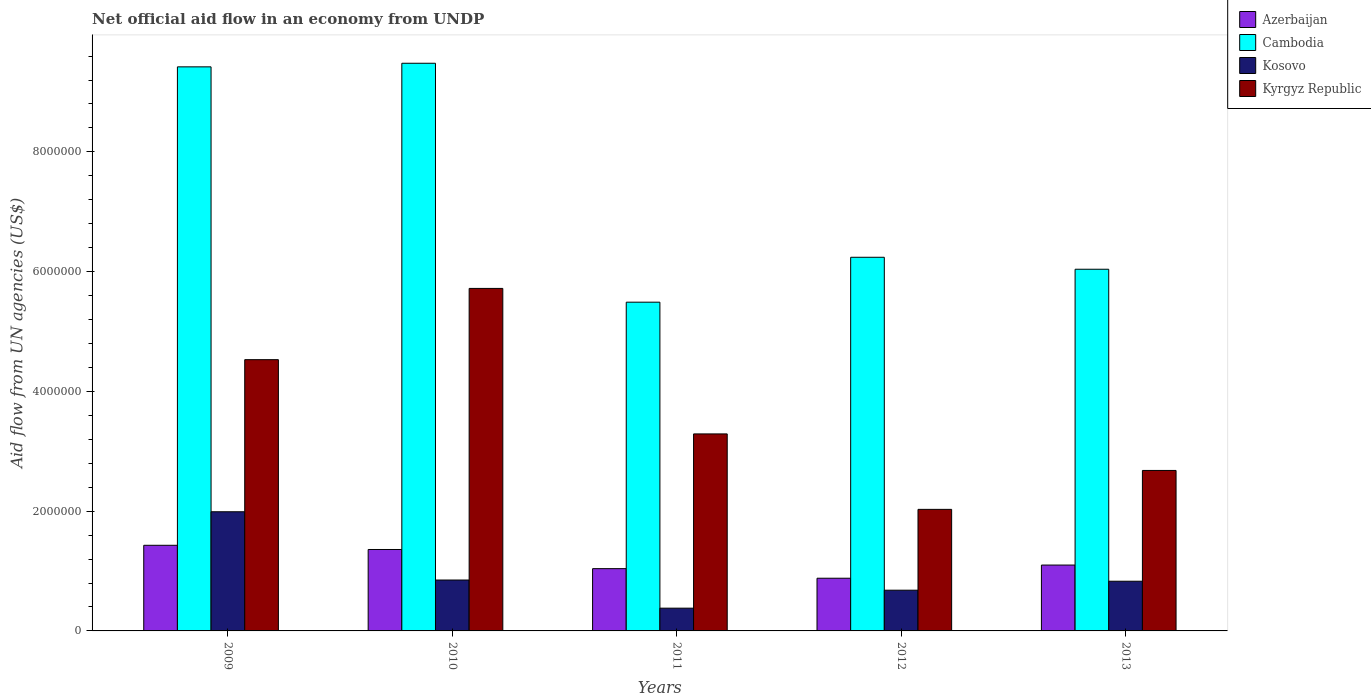How many different coloured bars are there?
Keep it short and to the point. 4. How many bars are there on the 4th tick from the left?
Your answer should be very brief. 4. How many bars are there on the 3rd tick from the right?
Provide a succinct answer. 4. What is the net official aid flow in Cambodia in 2013?
Keep it short and to the point. 6.04e+06. Across all years, what is the maximum net official aid flow in Kosovo?
Keep it short and to the point. 1.99e+06. Across all years, what is the minimum net official aid flow in Azerbaijan?
Give a very brief answer. 8.80e+05. In which year was the net official aid flow in Kosovo maximum?
Keep it short and to the point. 2009. What is the total net official aid flow in Cambodia in the graph?
Provide a short and direct response. 3.67e+07. What is the difference between the net official aid flow in Azerbaijan in 2011 and that in 2013?
Offer a very short reply. -6.00e+04. What is the difference between the net official aid flow in Azerbaijan in 2011 and the net official aid flow in Cambodia in 2009?
Make the answer very short. -8.38e+06. What is the average net official aid flow in Kyrgyz Republic per year?
Make the answer very short. 3.65e+06. In the year 2013, what is the difference between the net official aid flow in Kosovo and net official aid flow in Cambodia?
Offer a very short reply. -5.21e+06. In how many years, is the net official aid flow in Kyrgyz Republic greater than 5600000 US$?
Offer a very short reply. 1. What is the ratio of the net official aid flow in Kosovo in 2009 to that in 2012?
Ensure brevity in your answer.  2.93. Is the difference between the net official aid flow in Kosovo in 2011 and 2012 greater than the difference between the net official aid flow in Cambodia in 2011 and 2012?
Give a very brief answer. Yes. What is the difference between the highest and the second highest net official aid flow in Kyrgyz Republic?
Give a very brief answer. 1.19e+06. What is the difference between the highest and the lowest net official aid flow in Cambodia?
Your response must be concise. 3.99e+06. Is the sum of the net official aid flow in Kosovo in 2011 and 2013 greater than the maximum net official aid flow in Kyrgyz Republic across all years?
Your answer should be compact. No. Is it the case that in every year, the sum of the net official aid flow in Cambodia and net official aid flow in Kosovo is greater than the sum of net official aid flow in Kyrgyz Republic and net official aid flow in Azerbaijan?
Keep it short and to the point. No. What does the 2nd bar from the left in 2010 represents?
Offer a terse response. Cambodia. What does the 4th bar from the right in 2011 represents?
Provide a succinct answer. Azerbaijan. Are all the bars in the graph horizontal?
Provide a succinct answer. No. How many years are there in the graph?
Provide a succinct answer. 5. Does the graph contain any zero values?
Your answer should be compact. No. Does the graph contain grids?
Provide a short and direct response. No. Where does the legend appear in the graph?
Keep it short and to the point. Top right. What is the title of the graph?
Ensure brevity in your answer.  Net official aid flow in an economy from UNDP. Does "Kosovo" appear as one of the legend labels in the graph?
Provide a succinct answer. Yes. What is the label or title of the Y-axis?
Give a very brief answer. Aid flow from UN agencies (US$). What is the Aid flow from UN agencies (US$) of Azerbaijan in 2009?
Your answer should be very brief. 1.43e+06. What is the Aid flow from UN agencies (US$) of Cambodia in 2009?
Ensure brevity in your answer.  9.42e+06. What is the Aid flow from UN agencies (US$) of Kosovo in 2009?
Give a very brief answer. 1.99e+06. What is the Aid flow from UN agencies (US$) in Kyrgyz Republic in 2009?
Your response must be concise. 4.53e+06. What is the Aid flow from UN agencies (US$) of Azerbaijan in 2010?
Give a very brief answer. 1.36e+06. What is the Aid flow from UN agencies (US$) of Cambodia in 2010?
Give a very brief answer. 9.48e+06. What is the Aid flow from UN agencies (US$) of Kosovo in 2010?
Make the answer very short. 8.50e+05. What is the Aid flow from UN agencies (US$) of Kyrgyz Republic in 2010?
Your answer should be compact. 5.72e+06. What is the Aid flow from UN agencies (US$) in Azerbaijan in 2011?
Offer a terse response. 1.04e+06. What is the Aid flow from UN agencies (US$) of Cambodia in 2011?
Your answer should be very brief. 5.49e+06. What is the Aid flow from UN agencies (US$) in Kosovo in 2011?
Make the answer very short. 3.80e+05. What is the Aid flow from UN agencies (US$) in Kyrgyz Republic in 2011?
Provide a succinct answer. 3.29e+06. What is the Aid flow from UN agencies (US$) of Azerbaijan in 2012?
Your answer should be very brief. 8.80e+05. What is the Aid flow from UN agencies (US$) in Cambodia in 2012?
Give a very brief answer. 6.24e+06. What is the Aid flow from UN agencies (US$) of Kosovo in 2012?
Provide a succinct answer. 6.80e+05. What is the Aid flow from UN agencies (US$) of Kyrgyz Republic in 2012?
Offer a very short reply. 2.03e+06. What is the Aid flow from UN agencies (US$) of Azerbaijan in 2013?
Your response must be concise. 1.10e+06. What is the Aid flow from UN agencies (US$) in Cambodia in 2013?
Offer a very short reply. 6.04e+06. What is the Aid flow from UN agencies (US$) of Kosovo in 2013?
Your response must be concise. 8.30e+05. What is the Aid flow from UN agencies (US$) of Kyrgyz Republic in 2013?
Make the answer very short. 2.68e+06. Across all years, what is the maximum Aid flow from UN agencies (US$) in Azerbaijan?
Make the answer very short. 1.43e+06. Across all years, what is the maximum Aid flow from UN agencies (US$) of Cambodia?
Provide a short and direct response. 9.48e+06. Across all years, what is the maximum Aid flow from UN agencies (US$) of Kosovo?
Your answer should be very brief. 1.99e+06. Across all years, what is the maximum Aid flow from UN agencies (US$) in Kyrgyz Republic?
Your answer should be very brief. 5.72e+06. Across all years, what is the minimum Aid flow from UN agencies (US$) in Azerbaijan?
Ensure brevity in your answer.  8.80e+05. Across all years, what is the minimum Aid flow from UN agencies (US$) in Cambodia?
Offer a very short reply. 5.49e+06. Across all years, what is the minimum Aid flow from UN agencies (US$) of Kyrgyz Republic?
Your answer should be compact. 2.03e+06. What is the total Aid flow from UN agencies (US$) of Azerbaijan in the graph?
Make the answer very short. 5.81e+06. What is the total Aid flow from UN agencies (US$) of Cambodia in the graph?
Ensure brevity in your answer.  3.67e+07. What is the total Aid flow from UN agencies (US$) in Kosovo in the graph?
Give a very brief answer. 4.73e+06. What is the total Aid flow from UN agencies (US$) of Kyrgyz Republic in the graph?
Make the answer very short. 1.82e+07. What is the difference between the Aid flow from UN agencies (US$) of Kosovo in 2009 and that in 2010?
Offer a terse response. 1.14e+06. What is the difference between the Aid flow from UN agencies (US$) of Kyrgyz Republic in 2009 and that in 2010?
Provide a short and direct response. -1.19e+06. What is the difference between the Aid flow from UN agencies (US$) of Azerbaijan in 2009 and that in 2011?
Keep it short and to the point. 3.90e+05. What is the difference between the Aid flow from UN agencies (US$) in Cambodia in 2009 and that in 2011?
Your answer should be compact. 3.93e+06. What is the difference between the Aid flow from UN agencies (US$) in Kosovo in 2009 and that in 2011?
Your answer should be very brief. 1.61e+06. What is the difference between the Aid flow from UN agencies (US$) in Kyrgyz Republic in 2009 and that in 2011?
Your answer should be very brief. 1.24e+06. What is the difference between the Aid flow from UN agencies (US$) in Azerbaijan in 2009 and that in 2012?
Your answer should be very brief. 5.50e+05. What is the difference between the Aid flow from UN agencies (US$) in Cambodia in 2009 and that in 2012?
Offer a very short reply. 3.18e+06. What is the difference between the Aid flow from UN agencies (US$) in Kosovo in 2009 and that in 2012?
Provide a succinct answer. 1.31e+06. What is the difference between the Aid flow from UN agencies (US$) in Kyrgyz Republic in 2009 and that in 2012?
Offer a terse response. 2.50e+06. What is the difference between the Aid flow from UN agencies (US$) of Cambodia in 2009 and that in 2013?
Make the answer very short. 3.38e+06. What is the difference between the Aid flow from UN agencies (US$) in Kosovo in 2009 and that in 2013?
Make the answer very short. 1.16e+06. What is the difference between the Aid flow from UN agencies (US$) in Kyrgyz Republic in 2009 and that in 2013?
Make the answer very short. 1.85e+06. What is the difference between the Aid flow from UN agencies (US$) of Cambodia in 2010 and that in 2011?
Your answer should be compact. 3.99e+06. What is the difference between the Aid flow from UN agencies (US$) in Kyrgyz Republic in 2010 and that in 2011?
Provide a succinct answer. 2.43e+06. What is the difference between the Aid flow from UN agencies (US$) of Cambodia in 2010 and that in 2012?
Give a very brief answer. 3.24e+06. What is the difference between the Aid flow from UN agencies (US$) in Kosovo in 2010 and that in 2012?
Offer a very short reply. 1.70e+05. What is the difference between the Aid flow from UN agencies (US$) of Kyrgyz Republic in 2010 and that in 2012?
Keep it short and to the point. 3.69e+06. What is the difference between the Aid flow from UN agencies (US$) in Cambodia in 2010 and that in 2013?
Make the answer very short. 3.44e+06. What is the difference between the Aid flow from UN agencies (US$) of Kyrgyz Republic in 2010 and that in 2013?
Give a very brief answer. 3.04e+06. What is the difference between the Aid flow from UN agencies (US$) in Cambodia in 2011 and that in 2012?
Offer a terse response. -7.50e+05. What is the difference between the Aid flow from UN agencies (US$) of Kyrgyz Republic in 2011 and that in 2012?
Your answer should be very brief. 1.26e+06. What is the difference between the Aid flow from UN agencies (US$) of Azerbaijan in 2011 and that in 2013?
Ensure brevity in your answer.  -6.00e+04. What is the difference between the Aid flow from UN agencies (US$) of Cambodia in 2011 and that in 2013?
Keep it short and to the point. -5.50e+05. What is the difference between the Aid flow from UN agencies (US$) of Kosovo in 2011 and that in 2013?
Keep it short and to the point. -4.50e+05. What is the difference between the Aid flow from UN agencies (US$) of Kyrgyz Republic in 2011 and that in 2013?
Offer a terse response. 6.10e+05. What is the difference between the Aid flow from UN agencies (US$) of Cambodia in 2012 and that in 2013?
Offer a very short reply. 2.00e+05. What is the difference between the Aid flow from UN agencies (US$) in Kyrgyz Republic in 2012 and that in 2013?
Provide a succinct answer. -6.50e+05. What is the difference between the Aid flow from UN agencies (US$) of Azerbaijan in 2009 and the Aid flow from UN agencies (US$) of Cambodia in 2010?
Provide a succinct answer. -8.05e+06. What is the difference between the Aid flow from UN agencies (US$) of Azerbaijan in 2009 and the Aid flow from UN agencies (US$) of Kosovo in 2010?
Offer a terse response. 5.80e+05. What is the difference between the Aid flow from UN agencies (US$) of Azerbaijan in 2009 and the Aid flow from UN agencies (US$) of Kyrgyz Republic in 2010?
Your response must be concise. -4.29e+06. What is the difference between the Aid flow from UN agencies (US$) in Cambodia in 2009 and the Aid flow from UN agencies (US$) in Kosovo in 2010?
Ensure brevity in your answer.  8.57e+06. What is the difference between the Aid flow from UN agencies (US$) in Cambodia in 2009 and the Aid flow from UN agencies (US$) in Kyrgyz Republic in 2010?
Your answer should be compact. 3.70e+06. What is the difference between the Aid flow from UN agencies (US$) of Kosovo in 2009 and the Aid flow from UN agencies (US$) of Kyrgyz Republic in 2010?
Your answer should be compact. -3.73e+06. What is the difference between the Aid flow from UN agencies (US$) in Azerbaijan in 2009 and the Aid flow from UN agencies (US$) in Cambodia in 2011?
Give a very brief answer. -4.06e+06. What is the difference between the Aid flow from UN agencies (US$) of Azerbaijan in 2009 and the Aid flow from UN agencies (US$) of Kosovo in 2011?
Ensure brevity in your answer.  1.05e+06. What is the difference between the Aid flow from UN agencies (US$) in Azerbaijan in 2009 and the Aid flow from UN agencies (US$) in Kyrgyz Republic in 2011?
Your answer should be very brief. -1.86e+06. What is the difference between the Aid flow from UN agencies (US$) in Cambodia in 2009 and the Aid flow from UN agencies (US$) in Kosovo in 2011?
Provide a succinct answer. 9.04e+06. What is the difference between the Aid flow from UN agencies (US$) in Cambodia in 2009 and the Aid flow from UN agencies (US$) in Kyrgyz Republic in 2011?
Your answer should be very brief. 6.13e+06. What is the difference between the Aid flow from UN agencies (US$) of Kosovo in 2009 and the Aid flow from UN agencies (US$) of Kyrgyz Republic in 2011?
Offer a very short reply. -1.30e+06. What is the difference between the Aid flow from UN agencies (US$) of Azerbaijan in 2009 and the Aid flow from UN agencies (US$) of Cambodia in 2012?
Your answer should be compact. -4.81e+06. What is the difference between the Aid flow from UN agencies (US$) of Azerbaijan in 2009 and the Aid flow from UN agencies (US$) of Kosovo in 2012?
Keep it short and to the point. 7.50e+05. What is the difference between the Aid flow from UN agencies (US$) in Azerbaijan in 2009 and the Aid flow from UN agencies (US$) in Kyrgyz Republic in 2012?
Your response must be concise. -6.00e+05. What is the difference between the Aid flow from UN agencies (US$) in Cambodia in 2009 and the Aid flow from UN agencies (US$) in Kosovo in 2012?
Your response must be concise. 8.74e+06. What is the difference between the Aid flow from UN agencies (US$) in Cambodia in 2009 and the Aid flow from UN agencies (US$) in Kyrgyz Republic in 2012?
Your answer should be compact. 7.39e+06. What is the difference between the Aid flow from UN agencies (US$) of Azerbaijan in 2009 and the Aid flow from UN agencies (US$) of Cambodia in 2013?
Offer a terse response. -4.61e+06. What is the difference between the Aid flow from UN agencies (US$) of Azerbaijan in 2009 and the Aid flow from UN agencies (US$) of Kyrgyz Republic in 2013?
Your answer should be very brief. -1.25e+06. What is the difference between the Aid flow from UN agencies (US$) of Cambodia in 2009 and the Aid flow from UN agencies (US$) of Kosovo in 2013?
Your answer should be very brief. 8.59e+06. What is the difference between the Aid flow from UN agencies (US$) in Cambodia in 2009 and the Aid flow from UN agencies (US$) in Kyrgyz Republic in 2013?
Make the answer very short. 6.74e+06. What is the difference between the Aid flow from UN agencies (US$) of Kosovo in 2009 and the Aid flow from UN agencies (US$) of Kyrgyz Republic in 2013?
Give a very brief answer. -6.90e+05. What is the difference between the Aid flow from UN agencies (US$) in Azerbaijan in 2010 and the Aid flow from UN agencies (US$) in Cambodia in 2011?
Keep it short and to the point. -4.13e+06. What is the difference between the Aid flow from UN agencies (US$) of Azerbaijan in 2010 and the Aid flow from UN agencies (US$) of Kosovo in 2011?
Give a very brief answer. 9.80e+05. What is the difference between the Aid flow from UN agencies (US$) in Azerbaijan in 2010 and the Aid flow from UN agencies (US$) in Kyrgyz Republic in 2011?
Make the answer very short. -1.93e+06. What is the difference between the Aid flow from UN agencies (US$) in Cambodia in 2010 and the Aid flow from UN agencies (US$) in Kosovo in 2011?
Your response must be concise. 9.10e+06. What is the difference between the Aid flow from UN agencies (US$) in Cambodia in 2010 and the Aid flow from UN agencies (US$) in Kyrgyz Republic in 2011?
Offer a very short reply. 6.19e+06. What is the difference between the Aid flow from UN agencies (US$) in Kosovo in 2010 and the Aid flow from UN agencies (US$) in Kyrgyz Republic in 2011?
Your answer should be compact. -2.44e+06. What is the difference between the Aid flow from UN agencies (US$) in Azerbaijan in 2010 and the Aid flow from UN agencies (US$) in Cambodia in 2012?
Your answer should be compact. -4.88e+06. What is the difference between the Aid flow from UN agencies (US$) of Azerbaijan in 2010 and the Aid flow from UN agencies (US$) of Kosovo in 2012?
Offer a very short reply. 6.80e+05. What is the difference between the Aid flow from UN agencies (US$) in Azerbaijan in 2010 and the Aid flow from UN agencies (US$) in Kyrgyz Republic in 2012?
Keep it short and to the point. -6.70e+05. What is the difference between the Aid flow from UN agencies (US$) in Cambodia in 2010 and the Aid flow from UN agencies (US$) in Kosovo in 2012?
Provide a succinct answer. 8.80e+06. What is the difference between the Aid flow from UN agencies (US$) in Cambodia in 2010 and the Aid flow from UN agencies (US$) in Kyrgyz Republic in 2012?
Keep it short and to the point. 7.45e+06. What is the difference between the Aid flow from UN agencies (US$) of Kosovo in 2010 and the Aid flow from UN agencies (US$) of Kyrgyz Republic in 2012?
Provide a succinct answer. -1.18e+06. What is the difference between the Aid flow from UN agencies (US$) in Azerbaijan in 2010 and the Aid flow from UN agencies (US$) in Cambodia in 2013?
Your answer should be compact. -4.68e+06. What is the difference between the Aid flow from UN agencies (US$) in Azerbaijan in 2010 and the Aid flow from UN agencies (US$) in Kosovo in 2013?
Provide a succinct answer. 5.30e+05. What is the difference between the Aid flow from UN agencies (US$) in Azerbaijan in 2010 and the Aid flow from UN agencies (US$) in Kyrgyz Republic in 2013?
Your response must be concise. -1.32e+06. What is the difference between the Aid flow from UN agencies (US$) of Cambodia in 2010 and the Aid flow from UN agencies (US$) of Kosovo in 2013?
Provide a short and direct response. 8.65e+06. What is the difference between the Aid flow from UN agencies (US$) of Cambodia in 2010 and the Aid flow from UN agencies (US$) of Kyrgyz Republic in 2013?
Your answer should be very brief. 6.80e+06. What is the difference between the Aid flow from UN agencies (US$) in Kosovo in 2010 and the Aid flow from UN agencies (US$) in Kyrgyz Republic in 2013?
Give a very brief answer. -1.83e+06. What is the difference between the Aid flow from UN agencies (US$) in Azerbaijan in 2011 and the Aid flow from UN agencies (US$) in Cambodia in 2012?
Your response must be concise. -5.20e+06. What is the difference between the Aid flow from UN agencies (US$) in Azerbaijan in 2011 and the Aid flow from UN agencies (US$) in Kosovo in 2012?
Ensure brevity in your answer.  3.60e+05. What is the difference between the Aid flow from UN agencies (US$) in Azerbaijan in 2011 and the Aid flow from UN agencies (US$) in Kyrgyz Republic in 2012?
Provide a short and direct response. -9.90e+05. What is the difference between the Aid flow from UN agencies (US$) of Cambodia in 2011 and the Aid flow from UN agencies (US$) of Kosovo in 2012?
Offer a terse response. 4.81e+06. What is the difference between the Aid flow from UN agencies (US$) in Cambodia in 2011 and the Aid flow from UN agencies (US$) in Kyrgyz Republic in 2012?
Provide a succinct answer. 3.46e+06. What is the difference between the Aid flow from UN agencies (US$) in Kosovo in 2011 and the Aid flow from UN agencies (US$) in Kyrgyz Republic in 2012?
Provide a short and direct response. -1.65e+06. What is the difference between the Aid flow from UN agencies (US$) of Azerbaijan in 2011 and the Aid flow from UN agencies (US$) of Cambodia in 2013?
Your response must be concise. -5.00e+06. What is the difference between the Aid flow from UN agencies (US$) of Azerbaijan in 2011 and the Aid flow from UN agencies (US$) of Kosovo in 2013?
Your answer should be compact. 2.10e+05. What is the difference between the Aid flow from UN agencies (US$) of Azerbaijan in 2011 and the Aid flow from UN agencies (US$) of Kyrgyz Republic in 2013?
Keep it short and to the point. -1.64e+06. What is the difference between the Aid flow from UN agencies (US$) of Cambodia in 2011 and the Aid flow from UN agencies (US$) of Kosovo in 2013?
Your answer should be compact. 4.66e+06. What is the difference between the Aid flow from UN agencies (US$) of Cambodia in 2011 and the Aid flow from UN agencies (US$) of Kyrgyz Republic in 2013?
Provide a succinct answer. 2.81e+06. What is the difference between the Aid flow from UN agencies (US$) of Kosovo in 2011 and the Aid flow from UN agencies (US$) of Kyrgyz Republic in 2013?
Keep it short and to the point. -2.30e+06. What is the difference between the Aid flow from UN agencies (US$) in Azerbaijan in 2012 and the Aid flow from UN agencies (US$) in Cambodia in 2013?
Your response must be concise. -5.16e+06. What is the difference between the Aid flow from UN agencies (US$) in Azerbaijan in 2012 and the Aid flow from UN agencies (US$) in Kosovo in 2013?
Offer a very short reply. 5.00e+04. What is the difference between the Aid flow from UN agencies (US$) of Azerbaijan in 2012 and the Aid flow from UN agencies (US$) of Kyrgyz Republic in 2013?
Your answer should be very brief. -1.80e+06. What is the difference between the Aid flow from UN agencies (US$) in Cambodia in 2012 and the Aid flow from UN agencies (US$) in Kosovo in 2013?
Keep it short and to the point. 5.41e+06. What is the difference between the Aid flow from UN agencies (US$) in Cambodia in 2012 and the Aid flow from UN agencies (US$) in Kyrgyz Republic in 2013?
Your answer should be very brief. 3.56e+06. What is the average Aid flow from UN agencies (US$) of Azerbaijan per year?
Make the answer very short. 1.16e+06. What is the average Aid flow from UN agencies (US$) of Cambodia per year?
Keep it short and to the point. 7.33e+06. What is the average Aid flow from UN agencies (US$) of Kosovo per year?
Your response must be concise. 9.46e+05. What is the average Aid flow from UN agencies (US$) of Kyrgyz Republic per year?
Keep it short and to the point. 3.65e+06. In the year 2009, what is the difference between the Aid flow from UN agencies (US$) of Azerbaijan and Aid flow from UN agencies (US$) of Cambodia?
Provide a short and direct response. -7.99e+06. In the year 2009, what is the difference between the Aid flow from UN agencies (US$) of Azerbaijan and Aid flow from UN agencies (US$) of Kosovo?
Offer a very short reply. -5.60e+05. In the year 2009, what is the difference between the Aid flow from UN agencies (US$) of Azerbaijan and Aid flow from UN agencies (US$) of Kyrgyz Republic?
Ensure brevity in your answer.  -3.10e+06. In the year 2009, what is the difference between the Aid flow from UN agencies (US$) in Cambodia and Aid flow from UN agencies (US$) in Kosovo?
Provide a short and direct response. 7.43e+06. In the year 2009, what is the difference between the Aid flow from UN agencies (US$) in Cambodia and Aid flow from UN agencies (US$) in Kyrgyz Republic?
Provide a short and direct response. 4.89e+06. In the year 2009, what is the difference between the Aid flow from UN agencies (US$) in Kosovo and Aid flow from UN agencies (US$) in Kyrgyz Republic?
Your answer should be compact. -2.54e+06. In the year 2010, what is the difference between the Aid flow from UN agencies (US$) in Azerbaijan and Aid flow from UN agencies (US$) in Cambodia?
Make the answer very short. -8.12e+06. In the year 2010, what is the difference between the Aid flow from UN agencies (US$) of Azerbaijan and Aid flow from UN agencies (US$) of Kosovo?
Provide a short and direct response. 5.10e+05. In the year 2010, what is the difference between the Aid flow from UN agencies (US$) of Azerbaijan and Aid flow from UN agencies (US$) of Kyrgyz Republic?
Keep it short and to the point. -4.36e+06. In the year 2010, what is the difference between the Aid flow from UN agencies (US$) of Cambodia and Aid flow from UN agencies (US$) of Kosovo?
Keep it short and to the point. 8.63e+06. In the year 2010, what is the difference between the Aid flow from UN agencies (US$) in Cambodia and Aid flow from UN agencies (US$) in Kyrgyz Republic?
Your answer should be compact. 3.76e+06. In the year 2010, what is the difference between the Aid flow from UN agencies (US$) in Kosovo and Aid flow from UN agencies (US$) in Kyrgyz Republic?
Provide a succinct answer. -4.87e+06. In the year 2011, what is the difference between the Aid flow from UN agencies (US$) of Azerbaijan and Aid flow from UN agencies (US$) of Cambodia?
Offer a terse response. -4.45e+06. In the year 2011, what is the difference between the Aid flow from UN agencies (US$) of Azerbaijan and Aid flow from UN agencies (US$) of Kosovo?
Your answer should be very brief. 6.60e+05. In the year 2011, what is the difference between the Aid flow from UN agencies (US$) of Azerbaijan and Aid flow from UN agencies (US$) of Kyrgyz Republic?
Ensure brevity in your answer.  -2.25e+06. In the year 2011, what is the difference between the Aid flow from UN agencies (US$) of Cambodia and Aid flow from UN agencies (US$) of Kosovo?
Make the answer very short. 5.11e+06. In the year 2011, what is the difference between the Aid flow from UN agencies (US$) in Cambodia and Aid flow from UN agencies (US$) in Kyrgyz Republic?
Provide a short and direct response. 2.20e+06. In the year 2011, what is the difference between the Aid flow from UN agencies (US$) of Kosovo and Aid flow from UN agencies (US$) of Kyrgyz Republic?
Your answer should be very brief. -2.91e+06. In the year 2012, what is the difference between the Aid flow from UN agencies (US$) in Azerbaijan and Aid flow from UN agencies (US$) in Cambodia?
Your response must be concise. -5.36e+06. In the year 2012, what is the difference between the Aid flow from UN agencies (US$) of Azerbaijan and Aid flow from UN agencies (US$) of Kyrgyz Republic?
Offer a very short reply. -1.15e+06. In the year 2012, what is the difference between the Aid flow from UN agencies (US$) of Cambodia and Aid flow from UN agencies (US$) of Kosovo?
Ensure brevity in your answer.  5.56e+06. In the year 2012, what is the difference between the Aid flow from UN agencies (US$) in Cambodia and Aid flow from UN agencies (US$) in Kyrgyz Republic?
Keep it short and to the point. 4.21e+06. In the year 2012, what is the difference between the Aid flow from UN agencies (US$) in Kosovo and Aid flow from UN agencies (US$) in Kyrgyz Republic?
Your answer should be very brief. -1.35e+06. In the year 2013, what is the difference between the Aid flow from UN agencies (US$) of Azerbaijan and Aid flow from UN agencies (US$) of Cambodia?
Your answer should be very brief. -4.94e+06. In the year 2013, what is the difference between the Aid flow from UN agencies (US$) of Azerbaijan and Aid flow from UN agencies (US$) of Kyrgyz Republic?
Provide a succinct answer. -1.58e+06. In the year 2013, what is the difference between the Aid flow from UN agencies (US$) in Cambodia and Aid flow from UN agencies (US$) in Kosovo?
Your answer should be compact. 5.21e+06. In the year 2013, what is the difference between the Aid flow from UN agencies (US$) in Cambodia and Aid flow from UN agencies (US$) in Kyrgyz Republic?
Your response must be concise. 3.36e+06. In the year 2013, what is the difference between the Aid flow from UN agencies (US$) of Kosovo and Aid flow from UN agencies (US$) of Kyrgyz Republic?
Ensure brevity in your answer.  -1.85e+06. What is the ratio of the Aid flow from UN agencies (US$) in Azerbaijan in 2009 to that in 2010?
Provide a succinct answer. 1.05. What is the ratio of the Aid flow from UN agencies (US$) of Kosovo in 2009 to that in 2010?
Offer a very short reply. 2.34. What is the ratio of the Aid flow from UN agencies (US$) of Kyrgyz Republic in 2009 to that in 2010?
Make the answer very short. 0.79. What is the ratio of the Aid flow from UN agencies (US$) of Azerbaijan in 2009 to that in 2011?
Make the answer very short. 1.38. What is the ratio of the Aid flow from UN agencies (US$) in Cambodia in 2009 to that in 2011?
Give a very brief answer. 1.72. What is the ratio of the Aid flow from UN agencies (US$) of Kosovo in 2009 to that in 2011?
Keep it short and to the point. 5.24. What is the ratio of the Aid flow from UN agencies (US$) of Kyrgyz Republic in 2009 to that in 2011?
Your answer should be very brief. 1.38. What is the ratio of the Aid flow from UN agencies (US$) in Azerbaijan in 2009 to that in 2012?
Provide a short and direct response. 1.62. What is the ratio of the Aid flow from UN agencies (US$) in Cambodia in 2009 to that in 2012?
Give a very brief answer. 1.51. What is the ratio of the Aid flow from UN agencies (US$) in Kosovo in 2009 to that in 2012?
Ensure brevity in your answer.  2.93. What is the ratio of the Aid flow from UN agencies (US$) in Kyrgyz Republic in 2009 to that in 2012?
Provide a succinct answer. 2.23. What is the ratio of the Aid flow from UN agencies (US$) of Cambodia in 2009 to that in 2013?
Keep it short and to the point. 1.56. What is the ratio of the Aid flow from UN agencies (US$) in Kosovo in 2009 to that in 2013?
Make the answer very short. 2.4. What is the ratio of the Aid flow from UN agencies (US$) of Kyrgyz Republic in 2009 to that in 2013?
Keep it short and to the point. 1.69. What is the ratio of the Aid flow from UN agencies (US$) in Azerbaijan in 2010 to that in 2011?
Offer a terse response. 1.31. What is the ratio of the Aid flow from UN agencies (US$) of Cambodia in 2010 to that in 2011?
Your response must be concise. 1.73. What is the ratio of the Aid flow from UN agencies (US$) of Kosovo in 2010 to that in 2011?
Make the answer very short. 2.24. What is the ratio of the Aid flow from UN agencies (US$) of Kyrgyz Republic in 2010 to that in 2011?
Keep it short and to the point. 1.74. What is the ratio of the Aid flow from UN agencies (US$) of Azerbaijan in 2010 to that in 2012?
Offer a very short reply. 1.55. What is the ratio of the Aid flow from UN agencies (US$) of Cambodia in 2010 to that in 2012?
Provide a short and direct response. 1.52. What is the ratio of the Aid flow from UN agencies (US$) in Kyrgyz Republic in 2010 to that in 2012?
Offer a terse response. 2.82. What is the ratio of the Aid flow from UN agencies (US$) in Azerbaijan in 2010 to that in 2013?
Your answer should be compact. 1.24. What is the ratio of the Aid flow from UN agencies (US$) of Cambodia in 2010 to that in 2013?
Your answer should be very brief. 1.57. What is the ratio of the Aid flow from UN agencies (US$) in Kosovo in 2010 to that in 2013?
Provide a succinct answer. 1.02. What is the ratio of the Aid flow from UN agencies (US$) of Kyrgyz Republic in 2010 to that in 2013?
Your response must be concise. 2.13. What is the ratio of the Aid flow from UN agencies (US$) in Azerbaijan in 2011 to that in 2012?
Your answer should be very brief. 1.18. What is the ratio of the Aid flow from UN agencies (US$) in Cambodia in 2011 to that in 2012?
Your response must be concise. 0.88. What is the ratio of the Aid flow from UN agencies (US$) of Kosovo in 2011 to that in 2012?
Provide a succinct answer. 0.56. What is the ratio of the Aid flow from UN agencies (US$) in Kyrgyz Republic in 2011 to that in 2012?
Offer a terse response. 1.62. What is the ratio of the Aid flow from UN agencies (US$) of Azerbaijan in 2011 to that in 2013?
Your answer should be compact. 0.95. What is the ratio of the Aid flow from UN agencies (US$) of Cambodia in 2011 to that in 2013?
Ensure brevity in your answer.  0.91. What is the ratio of the Aid flow from UN agencies (US$) of Kosovo in 2011 to that in 2013?
Your answer should be compact. 0.46. What is the ratio of the Aid flow from UN agencies (US$) of Kyrgyz Republic in 2011 to that in 2013?
Ensure brevity in your answer.  1.23. What is the ratio of the Aid flow from UN agencies (US$) of Cambodia in 2012 to that in 2013?
Provide a succinct answer. 1.03. What is the ratio of the Aid flow from UN agencies (US$) in Kosovo in 2012 to that in 2013?
Your answer should be very brief. 0.82. What is the ratio of the Aid flow from UN agencies (US$) in Kyrgyz Republic in 2012 to that in 2013?
Your answer should be very brief. 0.76. What is the difference between the highest and the second highest Aid flow from UN agencies (US$) in Kosovo?
Offer a terse response. 1.14e+06. What is the difference between the highest and the second highest Aid flow from UN agencies (US$) in Kyrgyz Republic?
Keep it short and to the point. 1.19e+06. What is the difference between the highest and the lowest Aid flow from UN agencies (US$) in Cambodia?
Offer a terse response. 3.99e+06. What is the difference between the highest and the lowest Aid flow from UN agencies (US$) in Kosovo?
Your response must be concise. 1.61e+06. What is the difference between the highest and the lowest Aid flow from UN agencies (US$) in Kyrgyz Republic?
Make the answer very short. 3.69e+06. 